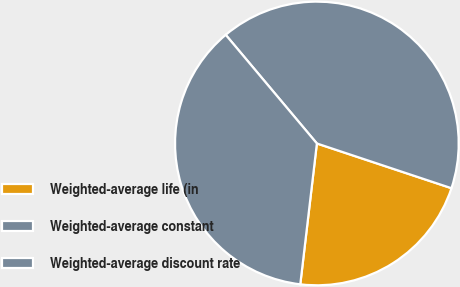Convert chart to OTSL. <chart><loc_0><loc_0><loc_500><loc_500><pie_chart><fcel>Weighted-average life (in<fcel>Weighted-average constant<fcel>Weighted-average discount rate<nl><fcel>21.76%<fcel>41.22%<fcel>37.02%<nl></chart> 